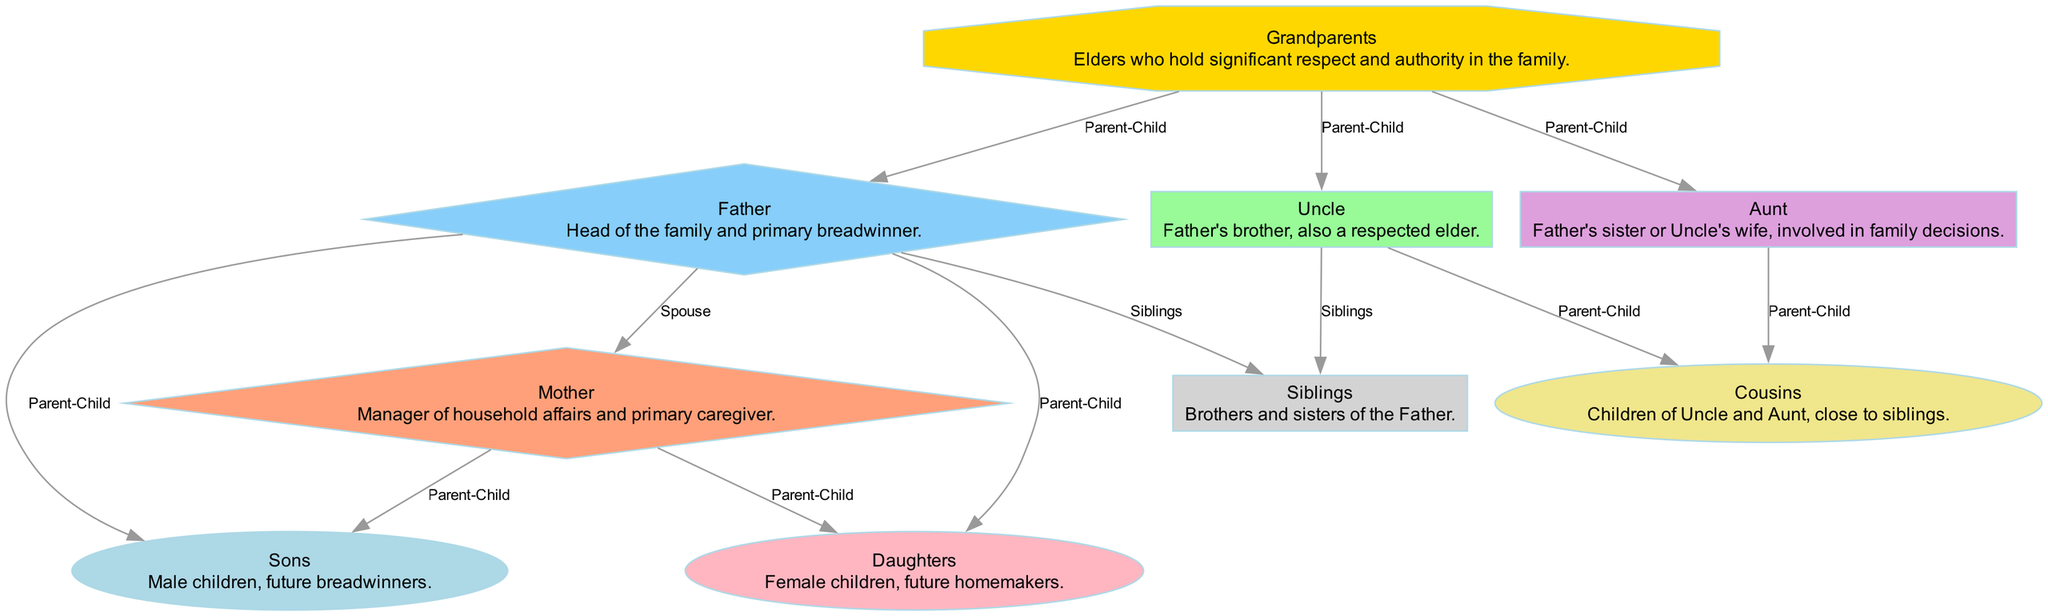What is the top node in the diagram? The top node represents the "Grandparents," as they are placed at the highest hierarchical position in the family structure. This shows their significance and respect.
Answer: Grandparents How many direct children does the Father have? The Father has two direct children, namely "Sons" and "Daughters," shown as parent-child connections in the diagram leading from Father to these nodes.
Answer: 2 What relationship does the Uncle have with the Cousins? The Uncle is the parent to the Cousins, as depicted by the directed edge from Uncle to Cousins, labeling their relationship as "Parent-Child."
Answer: Parent-Child Who is the manager of household affairs in the family? The Mother is designated as the manager of household affairs as described in her node, demonstrating her role within the family structure.
Answer: Mother How many siblings does the Father have? The Father has one sibling, represented by the "Siblings" node connecting back to the Father in the diagram. However, the exact number isn't specified, so it's assumed to refer to the concept of having brothers and sisters.
Answer: Siblings What is the primary role of Sons in this family structure? The Sons are referred to as future breadwinners, indicating their expected role as providers in the family as they mature.
Answer: Future breadwinners Which family member is indicated as the spouse of the Father? The diagram shows a direct relationship between the Father and the Mother, marked as "Spouse," thus identifying the Mother as his spouse.
Answer: Mother What color represents the Grandparents node in the diagram? The Grandparents node is colored gold, indicated by the style attributes in the diagram, which signifies their respect and importance.
Answer: Gold How many family members are directly related to the Father in the diagram? The Father is directly related to four family members: the Mother, Sons, Daughters, and Siblings, as shown in multiple edges starting from the Father node towards these relationships.
Answer: 4 